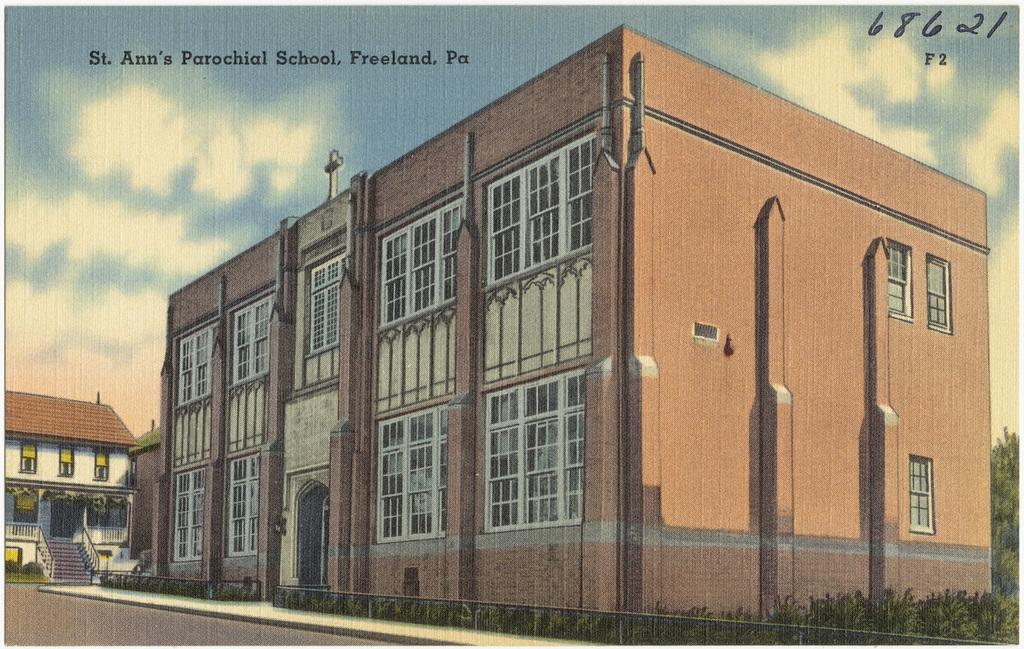St. ann's is in which city and state?
Provide a succinct answer. Freeland, pa. What is the name of the school?
Offer a terse response. St. ann's parochial school. 